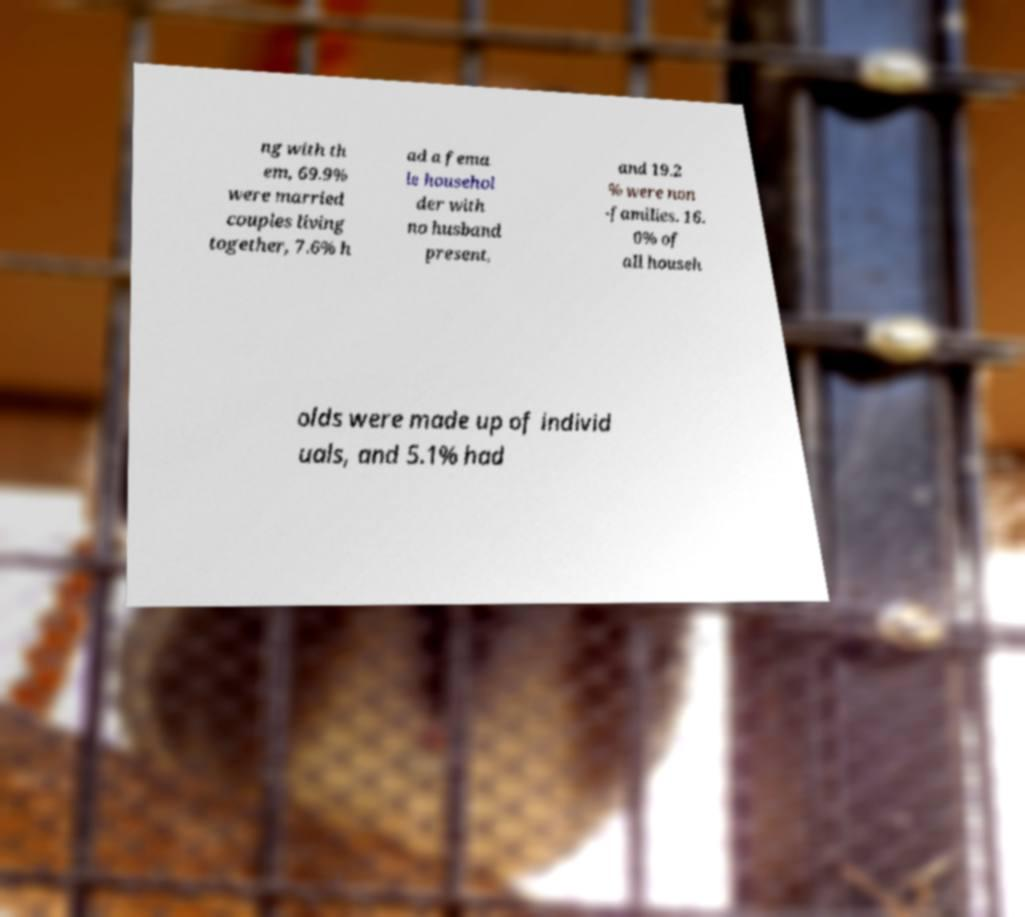Can you read and provide the text displayed in the image?This photo seems to have some interesting text. Can you extract and type it out for me? ng with th em, 69.9% were married couples living together, 7.6% h ad a fema le househol der with no husband present, and 19.2 % were non -families. 16. 0% of all househ olds were made up of individ uals, and 5.1% had 